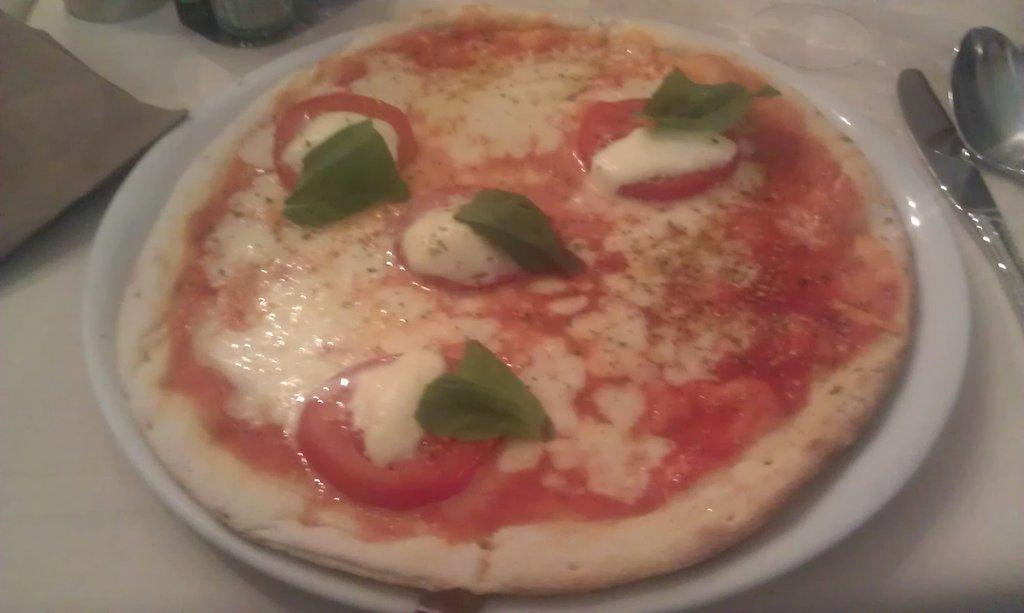What is on the plate that is visible in the image? There is a plate with food items in the image. How many tomato slices are on the plate? There are four tomato slices on the plate. What else is on the plate besides the tomato slices? There are four leaves on the plate. What utensils are beside the plate? There is a spoon and a knife beside the plate. How many lettuce leaves are on the plate? There are no lettuce leaves mentioned in the facts provided. 